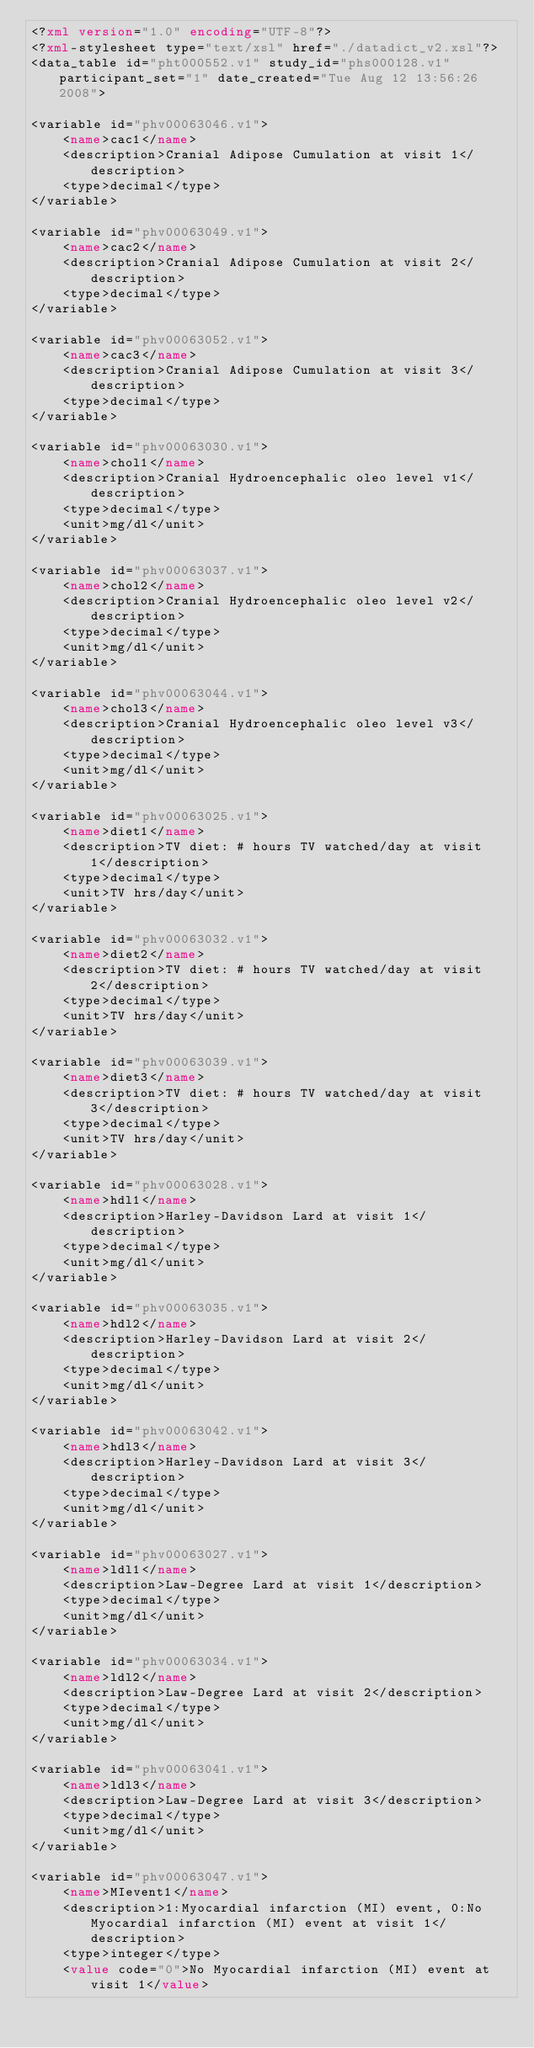Convert code to text. <code><loc_0><loc_0><loc_500><loc_500><_XML_><?xml version="1.0" encoding="UTF-8"?>
<?xml-stylesheet type="text/xsl" href="./datadict_v2.xsl"?>
<data_table id="pht000552.v1" study_id="phs000128.v1" participant_set="1" date_created="Tue Aug 12 13:56:26 2008">

<variable id="phv00063046.v1">
	<name>cac1</name>
	<description>Cranial Adipose Cumulation at visit 1</description>
	<type>decimal</type>
</variable>

<variable id="phv00063049.v1">
	<name>cac2</name>
	<description>Cranial Adipose Cumulation at visit 2</description>
	<type>decimal</type>
</variable>

<variable id="phv00063052.v1">
	<name>cac3</name>
	<description>Cranial Adipose Cumulation at visit 3</description>
	<type>decimal</type>
</variable>

<variable id="phv00063030.v1">
	<name>chol1</name>
	<description>Cranial Hydroencephalic oleo level v1</description>
	<type>decimal</type>
	<unit>mg/dl</unit>
</variable>

<variable id="phv00063037.v1">
	<name>chol2</name>
	<description>Cranial Hydroencephalic oleo level v2</description>
	<type>decimal</type>
	<unit>mg/dl</unit>
</variable>

<variable id="phv00063044.v1">
	<name>chol3</name>
	<description>Cranial Hydroencephalic oleo level v3</description>
	<type>decimal</type>
	<unit>mg/dl</unit>
</variable>

<variable id="phv00063025.v1">
	<name>diet1</name>
	<description>TV diet: # hours TV watched/day at visit 1</description>
	<type>decimal</type>
	<unit>TV hrs/day</unit>
</variable>

<variable id="phv00063032.v1">
	<name>diet2</name>
	<description>TV diet: # hours TV watched/day at visit 2</description>
	<type>decimal</type>
	<unit>TV hrs/day</unit>
</variable>

<variable id="phv00063039.v1">
	<name>diet3</name>
	<description>TV diet: # hours TV watched/day at visit 3</description>
	<type>decimal</type>
	<unit>TV hrs/day</unit>
</variable>

<variable id="phv00063028.v1">
	<name>hdl1</name>
	<description>Harley-Davidson Lard at visit 1</description>
	<type>decimal</type>
	<unit>mg/dl</unit>
</variable>

<variable id="phv00063035.v1">
	<name>hdl2</name>
	<description>Harley-Davidson Lard at visit 2</description>
	<type>decimal</type>
	<unit>mg/dl</unit>
</variable>

<variable id="phv00063042.v1">
	<name>hdl3</name>
	<description>Harley-Davidson Lard at visit 3</description>
	<type>decimal</type>
	<unit>mg/dl</unit>
</variable>

<variable id="phv00063027.v1">
	<name>ldl1</name>
	<description>Law-Degree Lard at visit 1</description>
	<type>decimal</type>
	<unit>mg/dl</unit>
</variable>

<variable id="phv00063034.v1">
	<name>ldl2</name>
	<description>Law-Degree Lard at visit 2</description>
	<type>decimal</type>
	<unit>mg/dl</unit>
</variable>

<variable id="phv00063041.v1">
	<name>ldl3</name>
	<description>Law-Degree Lard at visit 3</description>
	<type>decimal</type>
	<unit>mg/dl</unit>
</variable>

<variable id="phv00063047.v1">
	<name>MIevent1</name>
	<description>1:Myocardial infarction (MI) event, 0:No Myocardial infarction (MI) event at visit 1</description>
	<type>integer</type>
	<value code="0">No Myocardial infarction (MI) event at visit 1</value></code> 